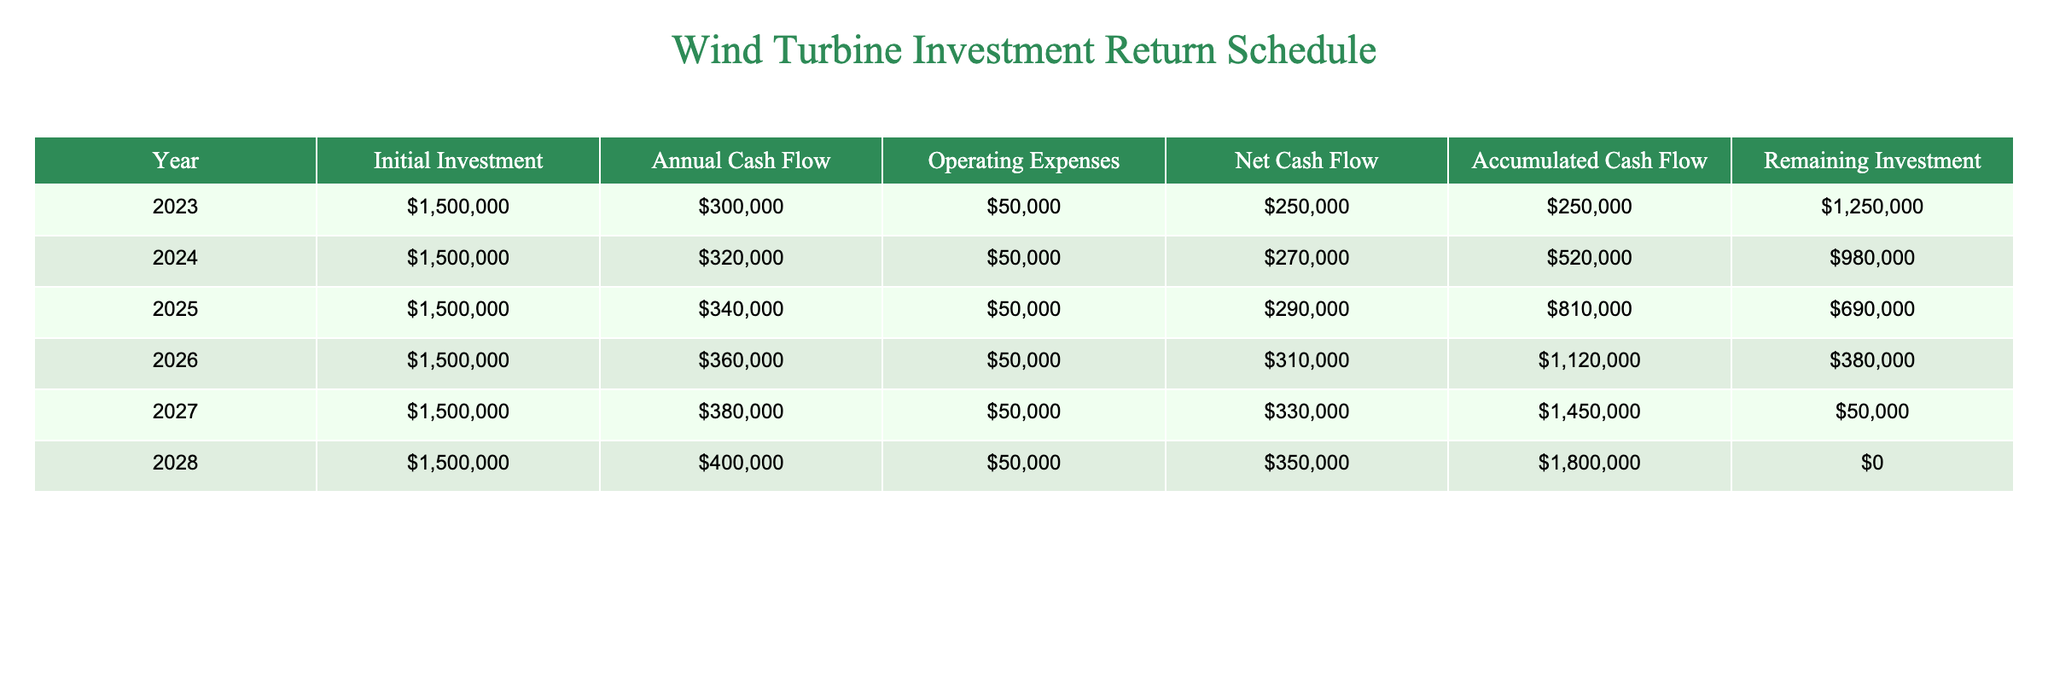What is the total initial investment made in 2023? The initial investment for 2023 is listed in the table as $1,500,000.
Answer: $1,500,000 In which year does the accumulated cash flow exceed $1,000,000? The accumulated cash flow at the end of 2026 is $1,120,000, which exceeds $1,000,000. In 2025 it is $810,000 and in 2024 it is $520,000.
Answer: 2026 What is the net cash flow for 2027? The net cash flow for 2027 is shown as $330,000 in the table.
Answer: $330,000 What is the average annual cash flow over the six years? To find the average annual cash flow, sum the annual cash flows from 2023 to 2028: $300,000 + $320,000 + $340,000 + $360,000 + $380,000 + $400,000 = $2,100,000, then divide by 6, giving an average of $350,000.
Answer: $350,000 Is there any remaining investment at the end of 2028? The remaining investment at the end of 2028 is $0, which indicates all initial investment has been recovered.
Answer: No 